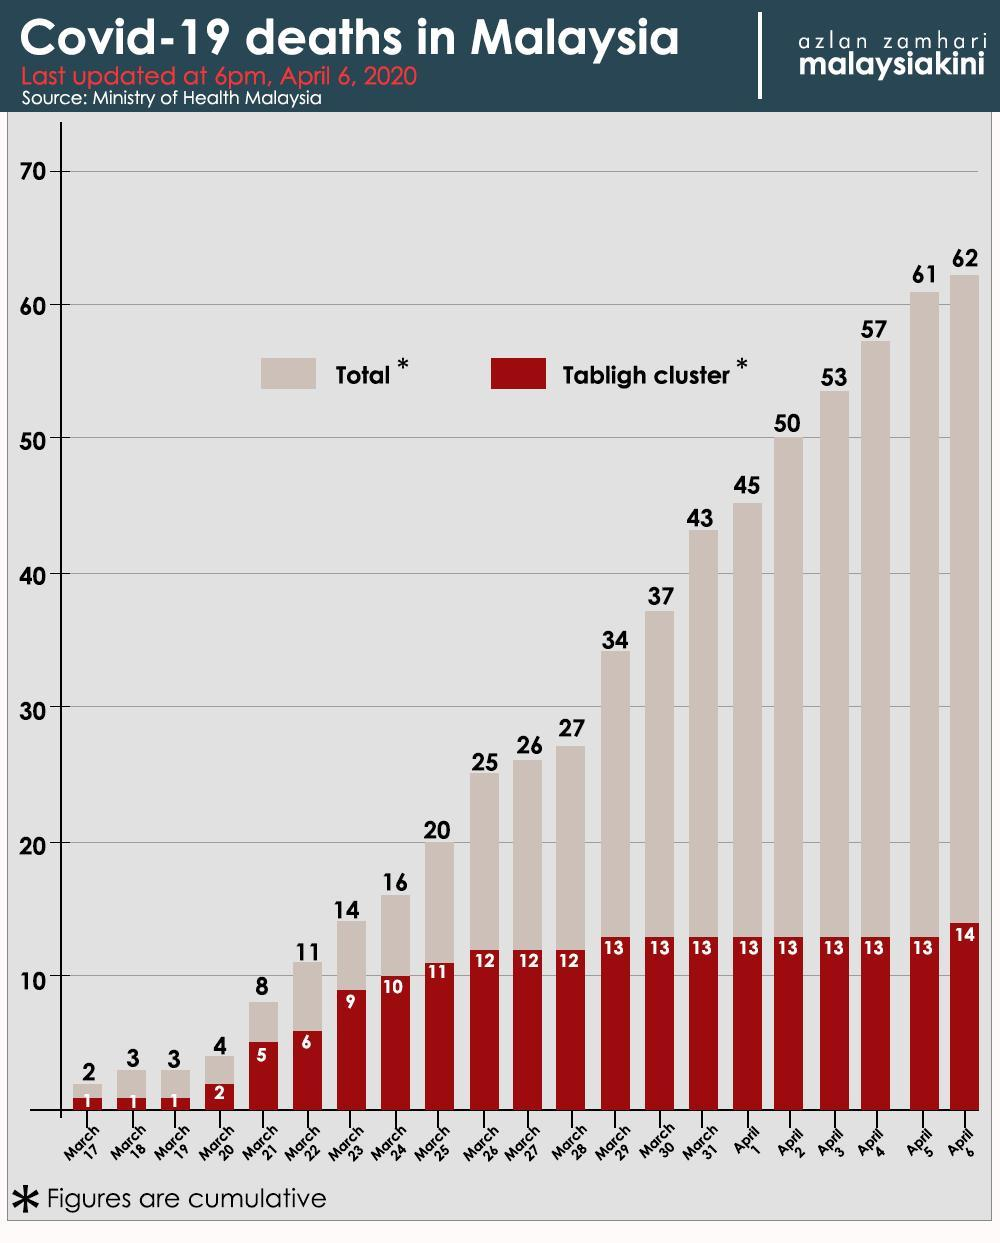What is the number of COVID-19 deaths in the Tabligh cluster in Malaysia as on April 6, 2020?
Answer the question with a short phrase. 14 What is the number of COVID-19 deaths in the Tabligh cluster in Malaysia as on April 5, 2020? 13 What is the total number of COVID-19 deaths in Malaysia as on March 25, 2020? 20 What is the total number of COVID-19 deaths in Malaysia as on April 2, 2020? 50 